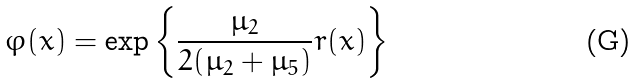Convert formula to latex. <formula><loc_0><loc_0><loc_500><loc_500>\varphi ( x ) = \exp \left \{ \frac { \mu _ { 2 } } { 2 ( \mu _ { 2 } + \mu _ { 5 } ) } r ( x ) \right \}</formula> 